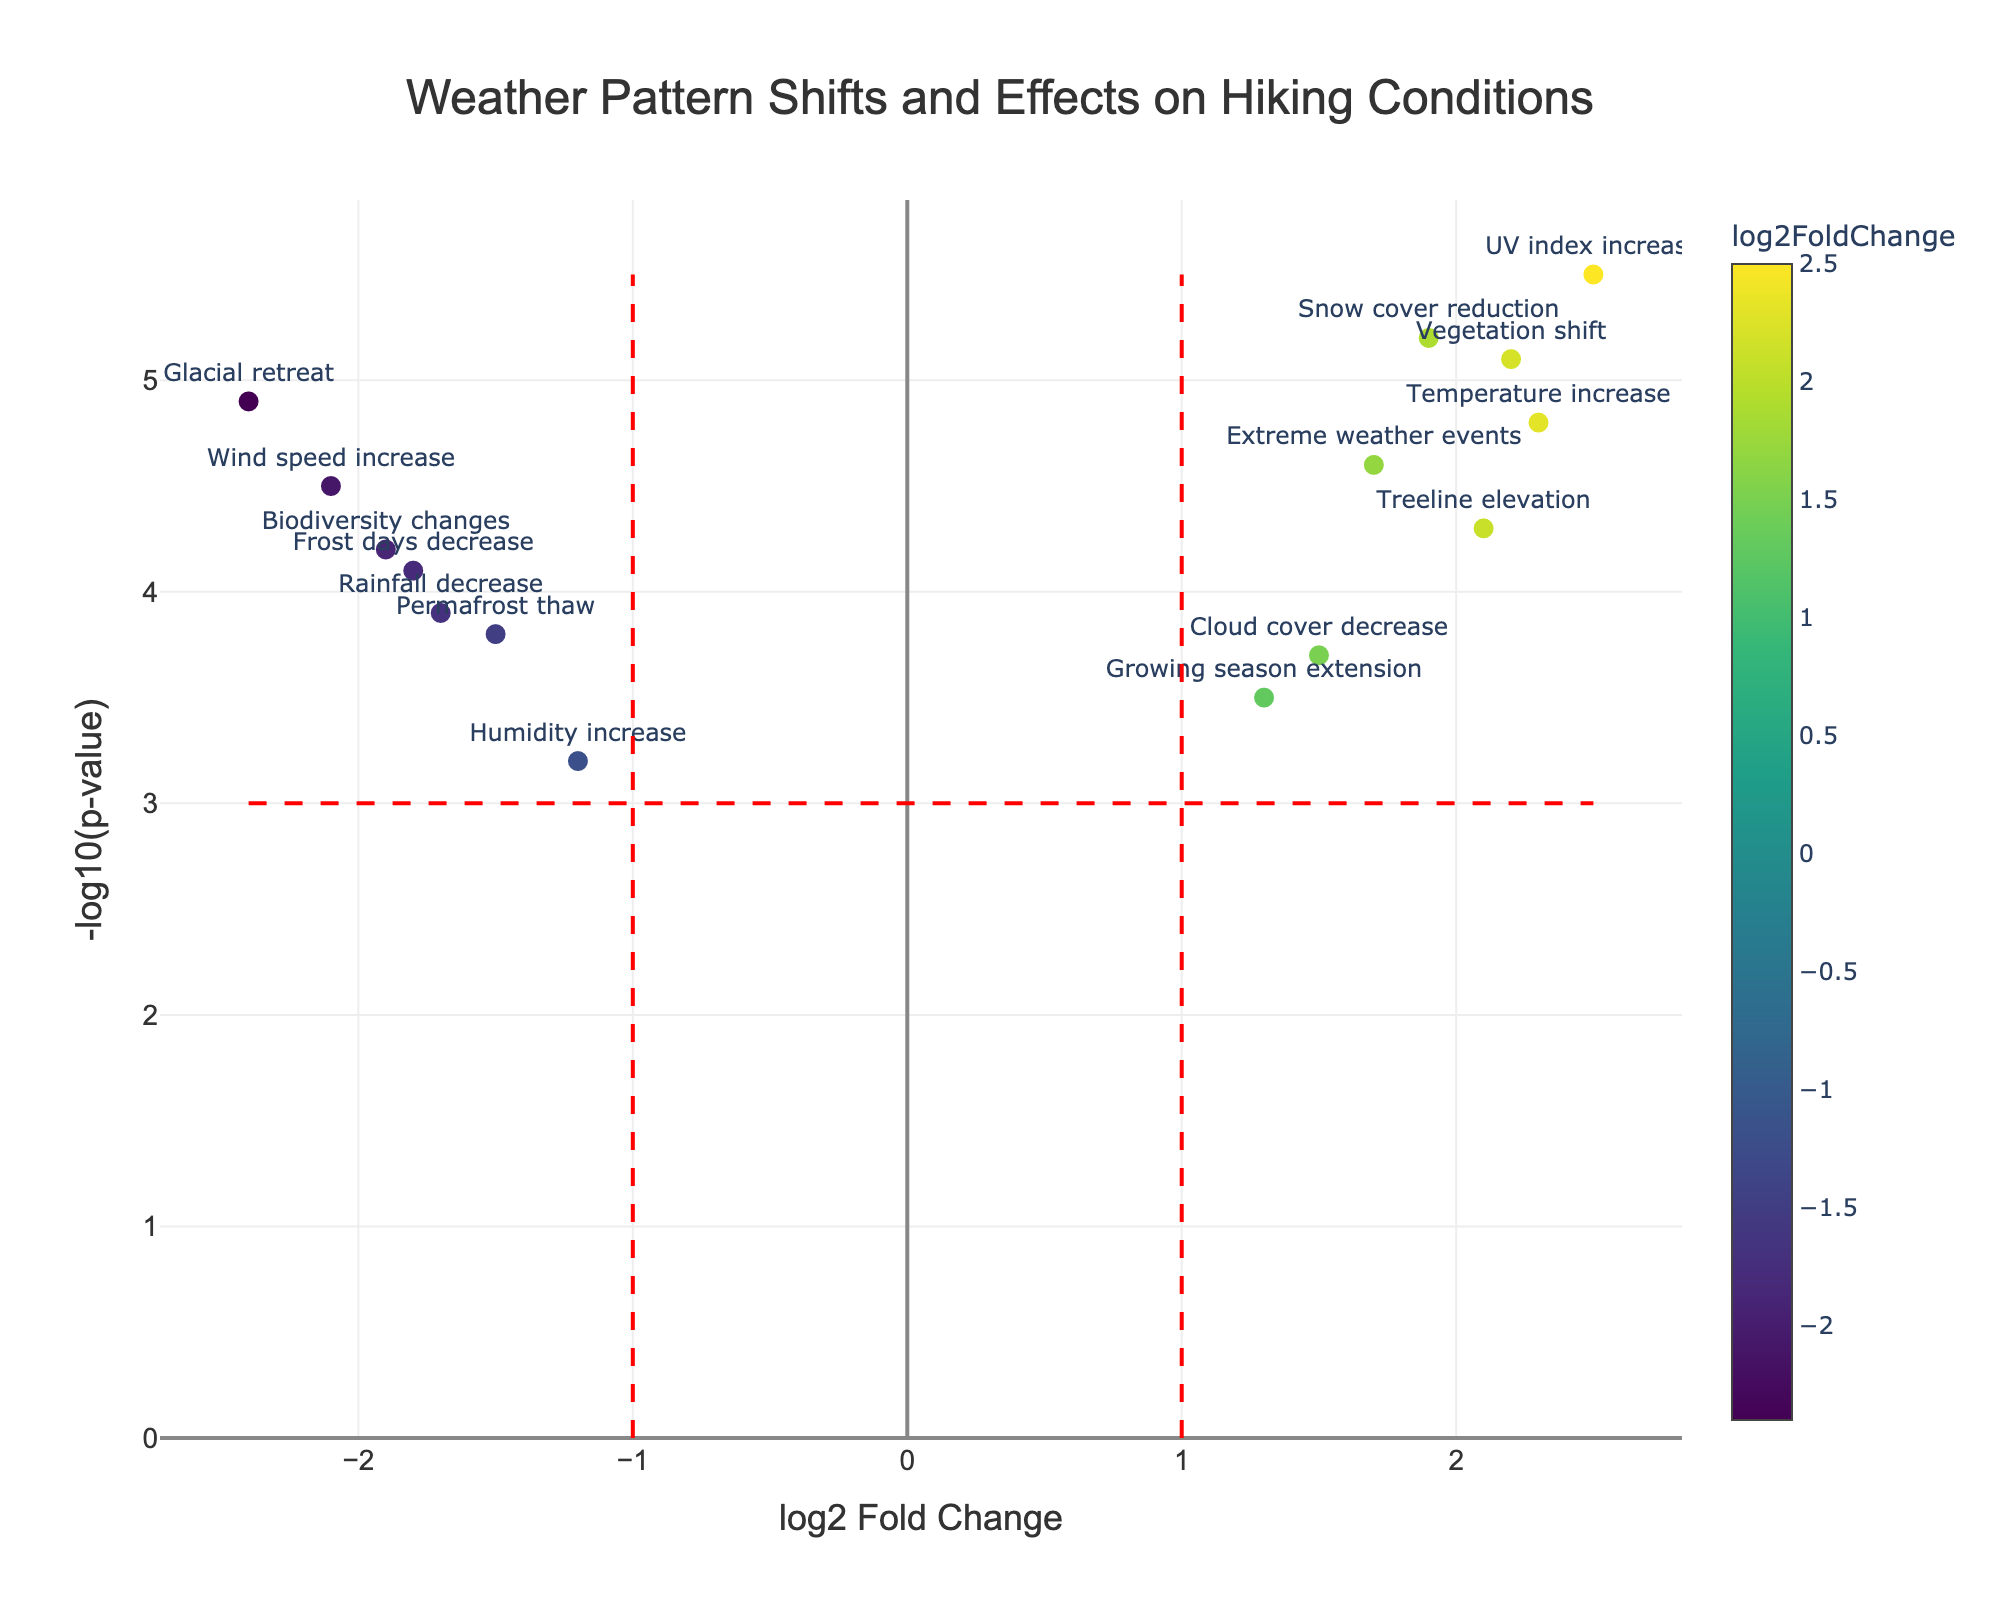What is the title of the figure? The title of the figure is typically located at the top of the plot. In this case, the title clearly states "Weather Pattern Shifts and Effects on Hiking Conditions".
Answer: Weather Pattern Shifts and Effects on Hiking Conditions What are the labeled axes? The x-axis is labeled "log2 Fold Change" and the y-axis is labeled "-log10(p-value)". These labels are essential for understanding the data being plotted.
Answer: log2 Fold Change and -log10(p-value) How many data points are shown in the plot? The data points are represented by the markers in the scatter plot. Counting them gives the total number of data points. There are 14 data points plotted.
Answer: 14 Which weather factor has the highest log2 fold change? By observing the x-axis, the weather factor with the highest log2 fold change will be the one farthest to the right. The "UV index increase" factor has the highest log2 fold change of 2.5.
Answer: UV index increase Which data points fall above the horizontal significance threshold line (set at -log10(p-value)=3)? We need to identify the data points with a y-value greater than 3. This includes most of the data points in the plot. All points are above this threshold.
Answer: All What is the range of -log10(p-values) in the plot? To find the range, identify the minimum and maximum values of the -log10(p-values) on the y-axis. The range is from 3.2 to 5.5.
Answer: 3.2 to 5.5 Which factor had the most significant decrease (in negative log2 fold change)? The factor with the most negative log2 fold change will be the farthest to the left. "Glacial retreat" has the most significant decrease with a log2 fold change of -2.4.
Answer: Glacial retreat How many weather factors have a log2 fold change greater than 2? Count the data points that have an x-value (log2 fold change) greater than 2. There are 3 such factors: "Temperature increase", "UV index increase", and "Vegetation shift".
Answer: 3 What is the log2 fold change and -log10(p-value) of "Snow cover reduction"? Locate the "Snow cover reduction" data point and read the corresponding x and y values from the plot. This factor has a log2 fold change of 1.9 and a -log10(p-value) of 5.2.
Answer: 1.9 and 5.2 Which weather factors lie between log2 fold changes of -2 and 2 and have a -log10(p-value) of at least 4? Identify the data points that fall within the x-range of -2 to 2 and have a y-value of at least 4. These include "Wind speed increase", "Frost days decrease", "Extreme weather events", "Treeline elevation", "Temperature increase", and "Rainfall decrease".
Answer: 6 Factors: Wind speed increase, Frost days decrease, Extreme weather events, Treeline elevation, Temperature increase, Rainfall decrease 